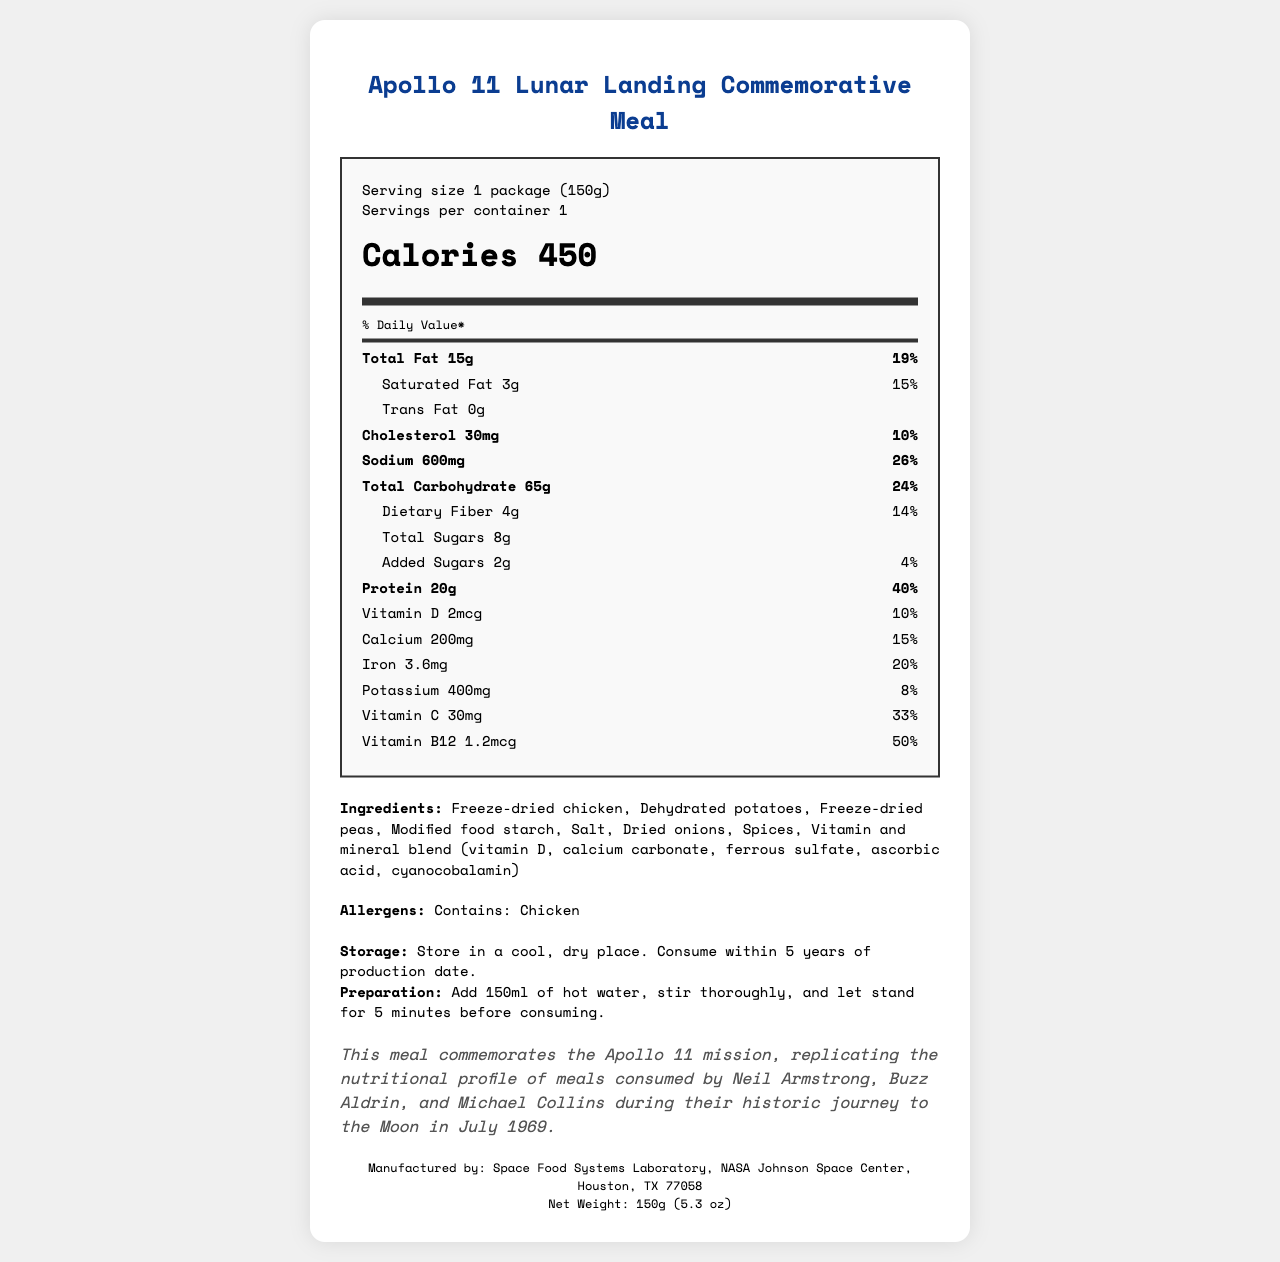What is the serving size of the Apollo 11 Lunar Landing Commemorative Meal? The serving size is clearly stated on the nutrition label as "1 package (150g)".
Answer: 1 package (150g) What is the amount of protein in the Apollo 11 Lunar Landing Commemorative Meal? The nutrition label indicates that there are 20 grams of protein in one serving of this meal.
Answer: 20g What percentage of the daily value of calcium does the Apollo 11 Lunar Landing Commemorative Meal provide? The daily value percentage for calcium is listed as 15% on the nutrition label.
Answer: 15% Which NASA mission does this meal commemorate? The historical note on the document states that this meal commemorates the Apollo 11 mission.
Answer: Apollo 11 Who were the astronauts that this meal commemorates? The historical note specifically mentions these three astronauts who were part of the Apollo 11 mission.
Answer: Neil Armstrong, Buzz Aldrin, and Michael Collins How much sodium does this meal contain? The nutrition label states that the meal contains 600 milligrams of sodium.
Answer: 600mg What are the allergens listed in the Apollo 11 Lunar Landing Commemorative Meal? The allergens section clearly mentions that it contains chicken.
Answer: Contains: Chicken What are the storage instructions for this meal? The storage instructions are provided under the instructions section of the document.
Answer: Store in a cool, dry place. Consume within 5 years of production date. How many grams of dietary fiber does this meal contain? The nutrition label lists the amount of dietary fiber in the meal as 4 grams.
Answer: 4g What step should be taken to prepare this meal? The preparation instructions clearly state the steps needed to prepare the meal.
Answer: Add 150ml of hot water, stir thoroughly, and let stand for 5 minutes before consuming. Which of the following ingredients are not included in the meal? A. Freeze-dried beef B. Dehydrated potatoes C. Freeze-dried peas The ingredients list includes dehydrated potatoes and freeze-dried peas, but freeze-dried beef is not listed.
Answer: A. Freeze-dried beef What is the daily value percentage of Vitamin C provided by this meal? A. 14% B. 20% C. 33% D. 50% The nutrition label indicates that Vitamin C is present at 33% of the daily value.
Answer: C. 33% Does this meal contain any trans fat? The nutrition label specifically states that it has 0 grams of trans fat.
Answer: No Summarize the key information of the Apollo 11 Lunar Landing Commemorative Meal. The summary highlights the commemorative aspect, nutritional content, ingredients, allergens, storage, preparation, and the manufacturer details as presented in the document.
Answer: This meal, commemorating the Apollo 11 mission, provides a detailed nutrition label listing various nutrients such as 450 calories, 15g of total fat, 20g of protein, and 600mg of sodium. It includes ingredients like freeze-dried chicken and dehydrated potatoes, with allergens including chicken. The meal should be stored in a cool, dry place and prepared by adding hot water. Manufactured by NASA's Space Food Systems Laboratory, it celebrates the historic journey of the Apollo 11 astronauts. Who manufactured the Apollo 11 Lunar Landing Commemorative Meal? The manufacturing information is clearly mentioned at the bottom of the document.
Answer: Space Food Systems Laboratory, NASA Johnson Space Center, Houston, TX 77058 What was the exact date when the Apollo 11 mission took place? The document does not provide the exact date of the Apollo 11 mission, though it mentions the journey took place in July 1969.
Answer: I don't know 